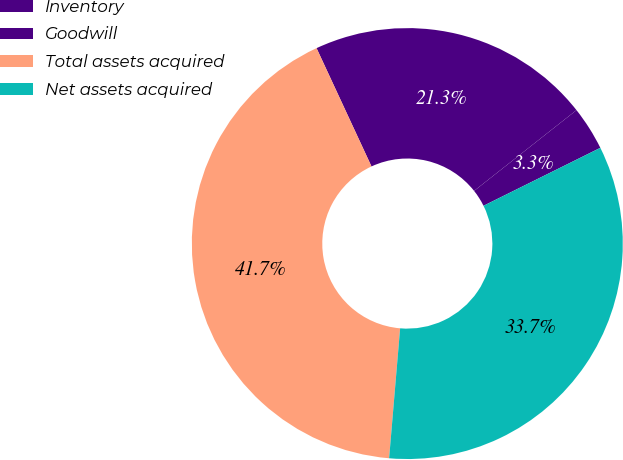Convert chart to OTSL. <chart><loc_0><loc_0><loc_500><loc_500><pie_chart><fcel>Inventory<fcel>Goodwill<fcel>Total assets acquired<fcel>Net assets acquired<nl><fcel>3.3%<fcel>21.29%<fcel>41.73%<fcel>33.67%<nl></chart> 